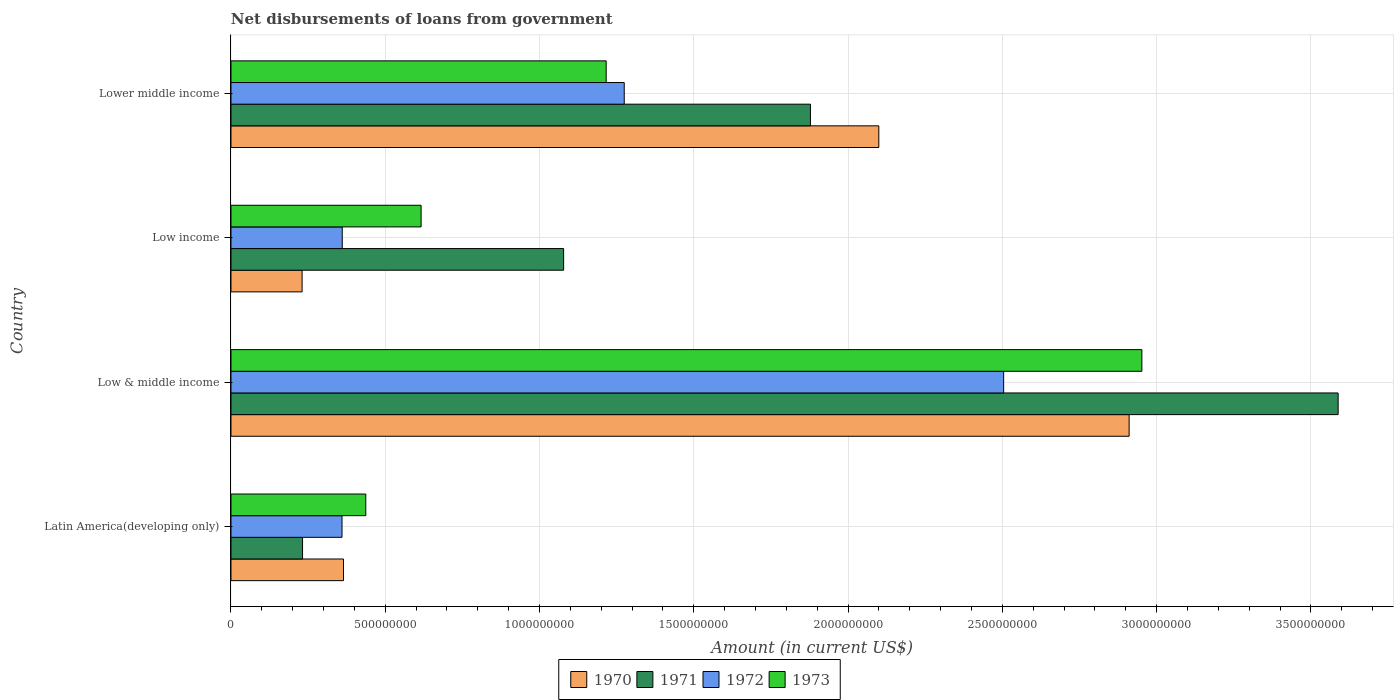How many groups of bars are there?
Your answer should be very brief. 4. How many bars are there on the 1st tick from the top?
Keep it short and to the point. 4. What is the label of the 2nd group of bars from the top?
Your answer should be compact. Low income. What is the amount of loan disbursed from government in 1971 in Low income?
Offer a terse response. 1.08e+09. Across all countries, what is the maximum amount of loan disbursed from government in 1973?
Your answer should be compact. 2.95e+09. Across all countries, what is the minimum amount of loan disbursed from government in 1971?
Offer a terse response. 2.32e+08. In which country was the amount of loan disbursed from government in 1971 maximum?
Offer a terse response. Low & middle income. In which country was the amount of loan disbursed from government in 1972 minimum?
Make the answer very short. Latin America(developing only). What is the total amount of loan disbursed from government in 1971 in the graph?
Provide a succinct answer. 6.78e+09. What is the difference between the amount of loan disbursed from government in 1971 in Latin America(developing only) and that in Lower middle income?
Your answer should be compact. -1.65e+09. What is the difference between the amount of loan disbursed from government in 1972 in Latin America(developing only) and the amount of loan disbursed from government in 1970 in Lower middle income?
Give a very brief answer. -1.74e+09. What is the average amount of loan disbursed from government in 1970 per country?
Your response must be concise. 1.40e+09. What is the difference between the amount of loan disbursed from government in 1971 and amount of loan disbursed from government in 1972 in Low income?
Provide a succinct answer. 7.17e+08. What is the ratio of the amount of loan disbursed from government in 1971 in Latin America(developing only) to that in Lower middle income?
Keep it short and to the point. 0.12. Is the amount of loan disbursed from government in 1971 in Low & middle income less than that in Lower middle income?
Ensure brevity in your answer.  No. Is the difference between the amount of loan disbursed from government in 1971 in Low income and Lower middle income greater than the difference between the amount of loan disbursed from government in 1972 in Low income and Lower middle income?
Provide a short and direct response. Yes. What is the difference between the highest and the second highest amount of loan disbursed from government in 1970?
Keep it short and to the point. 8.11e+08. What is the difference between the highest and the lowest amount of loan disbursed from government in 1972?
Give a very brief answer. 2.14e+09. In how many countries, is the amount of loan disbursed from government in 1972 greater than the average amount of loan disbursed from government in 1972 taken over all countries?
Provide a short and direct response. 2. Is it the case that in every country, the sum of the amount of loan disbursed from government in 1970 and amount of loan disbursed from government in 1971 is greater than the sum of amount of loan disbursed from government in 1973 and amount of loan disbursed from government in 1972?
Offer a terse response. No. What does the 4th bar from the bottom in Low income represents?
Keep it short and to the point. 1973. Is it the case that in every country, the sum of the amount of loan disbursed from government in 1971 and amount of loan disbursed from government in 1972 is greater than the amount of loan disbursed from government in 1970?
Offer a terse response. Yes. How many bars are there?
Your answer should be very brief. 16. How many countries are there in the graph?
Your response must be concise. 4. What is the difference between two consecutive major ticks on the X-axis?
Provide a succinct answer. 5.00e+08. Are the values on the major ticks of X-axis written in scientific E-notation?
Provide a succinct answer. No. Does the graph contain any zero values?
Keep it short and to the point. No. Does the graph contain grids?
Your response must be concise. Yes. How many legend labels are there?
Offer a terse response. 4. How are the legend labels stacked?
Provide a succinct answer. Horizontal. What is the title of the graph?
Provide a short and direct response. Net disbursements of loans from government. Does "1992" appear as one of the legend labels in the graph?
Keep it short and to the point. No. What is the label or title of the X-axis?
Keep it short and to the point. Amount (in current US$). What is the label or title of the Y-axis?
Your response must be concise. Country. What is the Amount (in current US$) in 1970 in Latin America(developing only)?
Provide a succinct answer. 3.65e+08. What is the Amount (in current US$) in 1971 in Latin America(developing only)?
Your response must be concise. 2.32e+08. What is the Amount (in current US$) in 1972 in Latin America(developing only)?
Offer a very short reply. 3.60e+08. What is the Amount (in current US$) of 1973 in Latin America(developing only)?
Your response must be concise. 4.37e+08. What is the Amount (in current US$) in 1970 in Low & middle income?
Ensure brevity in your answer.  2.91e+09. What is the Amount (in current US$) of 1971 in Low & middle income?
Your response must be concise. 3.59e+09. What is the Amount (in current US$) in 1972 in Low & middle income?
Your answer should be very brief. 2.50e+09. What is the Amount (in current US$) in 1973 in Low & middle income?
Keep it short and to the point. 2.95e+09. What is the Amount (in current US$) in 1970 in Low income?
Provide a short and direct response. 2.31e+08. What is the Amount (in current US$) of 1971 in Low income?
Offer a very short reply. 1.08e+09. What is the Amount (in current US$) in 1972 in Low income?
Provide a short and direct response. 3.61e+08. What is the Amount (in current US$) of 1973 in Low income?
Ensure brevity in your answer.  6.16e+08. What is the Amount (in current US$) in 1970 in Lower middle income?
Make the answer very short. 2.10e+09. What is the Amount (in current US$) in 1971 in Lower middle income?
Provide a short and direct response. 1.88e+09. What is the Amount (in current US$) in 1972 in Lower middle income?
Make the answer very short. 1.27e+09. What is the Amount (in current US$) of 1973 in Lower middle income?
Your answer should be very brief. 1.22e+09. Across all countries, what is the maximum Amount (in current US$) in 1970?
Offer a terse response. 2.91e+09. Across all countries, what is the maximum Amount (in current US$) in 1971?
Provide a succinct answer. 3.59e+09. Across all countries, what is the maximum Amount (in current US$) of 1972?
Your response must be concise. 2.50e+09. Across all countries, what is the maximum Amount (in current US$) of 1973?
Provide a succinct answer. 2.95e+09. Across all countries, what is the minimum Amount (in current US$) in 1970?
Offer a terse response. 2.31e+08. Across all countries, what is the minimum Amount (in current US$) of 1971?
Offer a very short reply. 2.32e+08. Across all countries, what is the minimum Amount (in current US$) of 1972?
Offer a terse response. 3.60e+08. Across all countries, what is the minimum Amount (in current US$) of 1973?
Your response must be concise. 4.37e+08. What is the total Amount (in current US$) of 1970 in the graph?
Offer a very short reply. 5.61e+09. What is the total Amount (in current US$) in 1971 in the graph?
Make the answer very short. 6.78e+09. What is the total Amount (in current US$) of 1972 in the graph?
Your response must be concise. 4.50e+09. What is the total Amount (in current US$) in 1973 in the graph?
Your answer should be compact. 5.22e+09. What is the difference between the Amount (in current US$) in 1970 in Latin America(developing only) and that in Low & middle income?
Your response must be concise. -2.55e+09. What is the difference between the Amount (in current US$) of 1971 in Latin America(developing only) and that in Low & middle income?
Offer a terse response. -3.36e+09. What is the difference between the Amount (in current US$) in 1972 in Latin America(developing only) and that in Low & middle income?
Offer a terse response. -2.14e+09. What is the difference between the Amount (in current US$) of 1973 in Latin America(developing only) and that in Low & middle income?
Give a very brief answer. -2.52e+09. What is the difference between the Amount (in current US$) in 1970 in Latin America(developing only) and that in Low income?
Offer a very short reply. 1.34e+08. What is the difference between the Amount (in current US$) in 1971 in Latin America(developing only) and that in Low income?
Offer a very short reply. -8.46e+08. What is the difference between the Amount (in current US$) of 1972 in Latin America(developing only) and that in Low income?
Offer a very short reply. -7.43e+05. What is the difference between the Amount (in current US$) of 1973 in Latin America(developing only) and that in Low income?
Your response must be concise. -1.79e+08. What is the difference between the Amount (in current US$) in 1970 in Latin America(developing only) and that in Lower middle income?
Ensure brevity in your answer.  -1.73e+09. What is the difference between the Amount (in current US$) in 1971 in Latin America(developing only) and that in Lower middle income?
Your answer should be compact. -1.65e+09. What is the difference between the Amount (in current US$) of 1972 in Latin America(developing only) and that in Lower middle income?
Offer a very short reply. -9.15e+08. What is the difference between the Amount (in current US$) of 1973 in Latin America(developing only) and that in Lower middle income?
Offer a very short reply. -7.79e+08. What is the difference between the Amount (in current US$) in 1970 in Low & middle income and that in Low income?
Keep it short and to the point. 2.68e+09. What is the difference between the Amount (in current US$) of 1971 in Low & middle income and that in Low income?
Provide a short and direct response. 2.51e+09. What is the difference between the Amount (in current US$) of 1972 in Low & middle income and that in Low income?
Provide a succinct answer. 2.14e+09. What is the difference between the Amount (in current US$) of 1973 in Low & middle income and that in Low income?
Offer a very short reply. 2.34e+09. What is the difference between the Amount (in current US$) in 1970 in Low & middle income and that in Lower middle income?
Give a very brief answer. 8.11e+08. What is the difference between the Amount (in current US$) in 1971 in Low & middle income and that in Lower middle income?
Offer a very short reply. 1.71e+09. What is the difference between the Amount (in current US$) in 1972 in Low & middle income and that in Lower middle income?
Provide a short and direct response. 1.23e+09. What is the difference between the Amount (in current US$) in 1973 in Low & middle income and that in Lower middle income?
Ensure brevity in your answer.  1.74e+09. What is the difference between the Amount (in current US$) in 1970 in Low income and that in Lower middle income?
Your response must be concise. -1.87e+09. What is the difference between the Amount (in current US$) of 1971 in Low income and that in Lower middle income?
Offer a very short reply. -8.00e+08. What is the difference between the Amount (in current US$) of 1972 in Low income and that in Lower middle income?
Provide a succinct answer. -9.14e+08. What is the difference between the Amount (in current US$) in 1973 in Low income and that in Lower middle income?
Provide a succinct answer. -6.00e+08. What is the difference between the Amount (in current US$) in 1970 in Latin America(developing only) and the Amount (in current US$) in 1971 in Low & middle income?
Your response must be concise. -3.22e+09. What is the difference between the Amount (in current US$) of 1970 in Latin America(developing only) and the Amount (in current US$) of 1972 in Low & middle income?
Your response must be concise. -2.14e+09. What is the difference between the Amount (in current US$) of 1970 in Latin America(developing only) and the Amount (in current US$) of 1973 in Low & middle income?
Your answer should be very brief. -2.59e+09. What is the difference between the Amount (in current US$) of 1971 in Latin America(developing only) and the Amount (in current US$) of 1972 in Low & middle income?
Your response must be concise. -2.27e+09. What is the difference between the Amount (in current US$) in 1971 in Latin America(developing only) and the Amount (in current US$) in 1973 in Low & middle income?
Your response must be concise. -2.72e+09. What is the difference between the Amount (in current US$) in 1972 in Latin America(developing only) and the Amount (in current US$) in 1973 in Low & middle income?
Keep it short and to the point. -2.59e+09. What is the difference between the Amount (in current US$) of 1970 in Latin America(developing only) and the Amount (in current US$) of 1971 in Low income?
Provide a short and direct response. -7.13e+08. What is the difference between the Amount (in current US$) of 1970 in Latin America(developing only) and the Amount (in current US$) of 1972 in Low income?
Your answer should be compact. 4.02e+06. What is the difference between the Amount (in current US$) in 1970 in Latin America(developing only) and the Amount (in current US$) in 1973 in Low income?
Your answer should be compact. -2.52e+08. What is the difference between the Amount (in current US$) of 1971 in Latin America(developing only) and the Amount (in current US$) of 1972 in Low income?
Keep it short and to the point. -1.29e+08. What is the difference between the Amount (in current US$) of 1971 in Latin America(developing only) and the Amount (in current US$) of 1973 in Low income?
Make the answer very short. -3.84e+08. What is the difference between the Amount (in current US$) in 1972 in Latin America(developing only) and the Amount (in current US$) in 1973 in Low income?
Keep it short and to the point. -2.56e+08. What is the difference between the Amount (in current US$) of 1970 in Latin America(developing only) and the Amount (in current US$) of 1971 in Lower middle income?
Provide a succinct answer. -1.51e+09. What is the difference between the Amount (in current US$) in 1970 in Latin America(developing only) and the Amount (in current US$) in 1972 in Lower middle income?
Keep it short and to the point. -9.10e+08. What is the difference between the Amount (in current US$) of 1970 in Latin America(developing only) and the Amount (in current US$) of 1973 in Lower middle income?
Provide a short and direct response. -8.51e+08. What is the difference between the Amount (in current US$) of 1971 in Latin America(developing only) and the Amount (in current US$) of 1972 in Lower middle income?
Provide a short and direct response. -1.04e+09. What is the difference between the Amount (in current US$) in 1971 in Latin America(developing only) and the Amount (in current US$) in 1973 in Lower middle income?
Ensure brevity in your answer.  -9.84e+08. What is the difference between the Amount (in current US$) in 1972 in Latin America(developing only) and the Amount (in current US$) in 1973 in Lower middle income?
Give a very brief answer. -8.56e+08. What is the difference between the Amount (in current US$) in 1970 in Low & middle income and the Amount (in current US$) in 1971 in Low income?
Your answer should be compact. 1.83e+09. What is the difference between the Amount (in current US$) of 1970 in Low & middle income and the Amount (in current US$) of 1972 in Low income?
Offer a terse response. 2.55e+09. What is the difference between the Amount (in current US$) of 1970 in Low & middle income and the Amount (in current US$) of 1973 in Low income?
Your answer should be very brief. 2.29e+09. What is the difference between the Amount (in current US$) in 1971 in Low & middle income and the Amount (in current US$) in 1972 in Low income?
Your response must be concise. 3.23e+09. What is the difference between the Amount (in current US$) in 1971 in Low & middle income and the Amount (in current US$) in 1973 in Low income?
Your answer should be compact. 2.97e+09. What is the difference between the Amount (in current US$) of 1972 in Low & middle income and the Amount (in current US$) of 1973 in Low income?
Provide a short and direct response. 1.89e+09. What is the difference between the Amount (in current US$) of 1970 in Low & middle income and the Amount (in current US$) of 1971 in Lower middle income?
Offer a terse response. 1.03e+09. What is the difference between the Amount (in current US$) in 1970 in Low & middle income and the Amount (in current US$) in 1972 in Lower middle income?
Keep it short and to the point. 1.64e+09. What is the difference between the Amount (in current US$) of 1970 in Low & middle income and the Amount (in current US$) of 1973 in Lower middle income?
Your answer should be compact. 1.69e+09. What is the difference between the Amount (in current US$) in 1971 in Low & middle income and the Amount (in current US$) in 1972 in Lower middle income?
Make the answer very short. 2.31e+09. What is the difference between the Amount (in current US$) of 1971 in Low & middle income and the Amount (in current US$) of 1973 in Lower middle income?
Your answer should be very brief. 2.37e+09. What is the difference between the Amount (in current US$) in 1972 in Low & middle income and the Amount (in current US$) in 1973 in Lower middle income?
Offer a very short reply. 1.29e+09. What is the difference between the Amount (in current US$) of 1970 in Low income and the Amount (in current US$) of 1971 in Lower middle income?
Your answer should be very brief. -1.65e+09. What is the difference between the Amount (in current US$) of 1970 in Low income and the Amount (in current US$) of 1972 in Lower middle income?
Give a very brief answer. -1.04e+09. What is the difference between the Amount (in current US$) of 1970 in Low income and the Amount (in current US$) of 1973 in Lower middle income?
Your response must be concise. -9.85e+08. What is the difference between the Amount (in current US$) in 1971 in Low income and the Amount (in current US$) in 1972 in Lower middle income?
Keep it short and to the point. -1.96e+08. What is the difference between the Amount (in current US$) of 1971 in Low income and the Amount (in current US$) of 1973 in Lower middle income?
Provide a short and direct response. -1.38e+08. What is the difference between the Amount (in current US$) of 1972 in Low income and the Amount (in current US$) of 1973 in Lower middle income?
Give a very brief answer. -8.55e+08. What is the average Amount (in current US$) of 1970 per country?
Your response must be concise. 1.40e+09. What is the average Amount (in current US$) of 1971 per country?
Make the answer very short. 1.69e+09. What is the average Amount (in current US$) of 1972 per country?
Give a very brief answer. 1.12e+09. What is the average Amount (in current US$) in 1973 per country?
Your response must be concise. 1.31e+09. What is the difference between the Amount (in current US$) in 1970 and Amount (in current US$) in 1971 in Latin America(developing only)?
Your response must be concise. 1.33e+08. What is the difference between the Amount (in current US$) in 1970 and Amount (in current US$) in 1972 in Latin America(developing only)?
Provide a short and direct response. 4.76e+06. What is the difference between the Amount (in current US$) in 1970 and Amount (in current US$) in 1973 in Latin America(developing only)?
Keep it short and to the point. -7.22e+07. What is the difference between the Amount (in current US$) in 1971 and Amount (in current US$) in 1972 in Latin America(developing only)?
Offer a terse response. -1.28e+08. What is the difference between the Amount (in current US$) in 1971 and Amount (in current US$) in 1973 in Latin America(developing only)?
Give a very brief answer. -2.05e+08. What is the difference between the Amount (in current US$) of 1972 and Amount (in current US$) of 1973 in Latin America(developing only)?
Provide a succinct answer. -7.70e+07. What is the difference between the Amount (in current US$) in 1970 and Amount (in current US$) in 1971 in Low & middle income?
Provide a short and direct response. -6.77e+08. What is the difference between the Amount (in current US$) of 1970 and Amount (in current US$) of 1972 in Low & middle income?
Provide a succinct answer. 4.07e+08. What is the difference between the Amount (in current US$) of 1970 and Amount (in current US$) of 1973 in Low & middle income?
Your answer should be very brief. -4.13e+07. What is the difference between the Amount (in current US$) in 1971 and Amount (in current US$) in 1972 in Low & middle income?
Your answer should be compact. 1.08e+09. What is the difference between the Amount (in current US$) in 1971 and Amount (in current US$) in 1973 in Low & middle income?
Your answer should be compact. 6.36e+08. What is the difference between the Amount (in current US$) of 1972 and Amount (in current US$) of 1973 in Low & middle income?
Ensure brevity in your answer.  -4.48e+08. What is the difference between the Amount (in current US$) in 1970 and Amount (in current US$) in 1971 in Low income?
Your response must be concise. -8.48e+08. What is the difference between the Amount (in current US$) of 1970 and Amount (in current US$) of 1972 in Low income?
Offer a very short reply. -1.30e+08. What is the difference between the Amount (in current US$) in 1970 and Amount (in current US$) in 1973 in Low income?
Provide a succinct answer. -3.86e+08. What is the difference between the Amount (in current US$) of 1971 and Amount (in current US$) of 1972 in Low income?
Your answer should be very brief. 7.17e+08. What is the difference between the Amount (in current US$) in 1971 and Amount (in current US$) in 1973 in Low income?
Your answer should be compact. 4.62e+08. What is the difference between the Amount (in current US$) of 1972 and Amount (in current US$) of 1973 in Low income?
Your response must be concise. -2.56e+08. What is the difference between the Amount (in current US$) of 1970 and Amount (in current US$) of 1971 in Lower middle income?
Make the answer very short. 2.22e+08. What is the difference between the Amount (in current US$) in 1970 and Amount (in current US$) in 1972 in Lower middle income?
Your answer should be very brief. 8.25e+08. What is the difference between the Amount (in current US$) of 1970 and Amount (in current US$) of 1973 in Lower middle income?
Ensure brevity in your answer.  8.84e+08. What is the difference between the Amount (in current US$) of 1971 and Amount (in current US$) of 1972 in Lower middle income?
Keep it short and to the point. 6.03e+08. What is the difference between the Amount (in current US$) in 1971 and Amount (in current US$) in 1973 in Lower middle income?
Your response must be concise. 6.62e+08. What is the difference between the Amount (in current US$) in 1972 and Amount (in current US$) in 1973 in Lower middle income?
Your answer should be very brief. 5.86e+07. What is the ratio of the Amount (in current US$) in 1970 in Latin America(developing only) to that in Low & middle income?
Keep it short and to the point. 0.13. What is the ratio of the Amount (in current US$) of 1971 in Latin America(developing only) to that in Low & middle income?
Offer a terse response. 0.06. What is the ratio of the Amount (in current US$) of 1972 in Latin America(developing only) to that in Low & middle income?
Make the answer very short. 0.14. What is the ratio of the Amount (in current US$) in 1973 in Latin America(developing only) to that in Low & middle income?
Ensure brevity in your answer.  0.15. What is the ratio of the Amount (in current US$) of 1970 in Latin America(developing only) to that in Low income?
Provide a succinct answer. 1.58. What is the ratio of the Amount (in current US$) of 1971 in Latin America(developing only) to that in Low income?
Provide a succinct answer. 0.22. What is the ratio of the Amount (in current US$) of 1973 in Latin America(developing only) to that in Low income?
Ensure brevity in your answer.  0.71. What is the ratio of the Amount (in current US$) in 1970 in Latin America(developing only) to that in Lower middle income?
Make the answer very short. 0.17. What is the ratio of the Amount (in current US$) of 1971 in Latin America(developing only) to that in Lower middle income?
Offer a terse response. 0.12. What is the ratio of the Amount (in current US$) of 1972 in Latin America(developing only) to that in Lower middle income?
Make the answer very short. 0.28. What is the ratio of the Amount (in current US$) in 1973 in Latin America(developing only) to that in Lower middle income?
Make the answer very short. 0.36. What is the ratio of the Amount (in current US$) of 1970 in Low & middle income to that in Low income?
Make the answer very short. 12.63. What is the ratio of the Amount (in current US$) in 1971 in Low & middle income to that in Low income?
Give a very brief answer. 3.33. What is the ratio of the Amount (in current US$) of 1972 in Low & middle income to that in Low income?
Your response must be concise. 6.94. What is the ratio of the Amount (in current US$) of 1973 in Low & middle income to that in Low income?
Offer a terse response. 4.79. What is the ratio of the Amount (in current US$) in 1970 in Low & middle income to that in Lower middle income?
Provide a short and direct response. 1.39. What is the ratio of the Amount (in current US$) of 1971 in Low & middle income to that in Lower middle income?
Offer a terse response. 1.91. What is the ratio of the Amount (in current US$) of 1972 in Low & middle income to that in Lower middle income?
Offer a very short reply. 1.96. What is the ratio of the Amount (in current US$) of 1973 in Low & middle income to that in Lower middle income?
Provide a succinct answer. 2.43. What is the ratio of the Amount (in current US$) of 1970 in Low income to that in Lower middle income?
Your response must be concise. 0.11. What is the ratio of the Amount (in current US$) of 1971 in Low income to that in Lower middle income?
Your response must be concise. 0.57. What is the ratio of the Amount (in current US$) in 1972 in Low income to that in Lower middle income?
Make the answer very short. 0.28. What is the ratio of the Amount (in current US$) in 1973 in Low income to that in Lower middle income?
Offer a terse response. 0.51. What is the difference between the highest and the second highest Amount (in current US$) of 1970?
Your response must be concise. 8.11e+08. What is the difference between the highest and the second highest Amount (in current US$) of 1971?
Provide a short and direct response. 1.71e+09. What is the difference between the highest and the second highest Amount (in current US$) in 1972?
Give a very brief answer. 1.23e+09. What is the difference between the highest and the second highest Amount (in current US$) in 1973?
Make the answer very short. 1.74e+09. What is the difference between the highest and the lowest Amount (in current US$) of 1970?
Offer a terse response. 2.68e+09. What is the difference between the highest and the lowest Amount (in current US$) of 1971?
Your response must be concise. 3.36e+09. What is the difference between the highest and the lowest Amount (in current US$) of 1972?
Keep it short and to the point. 2.14e+09. What is the difference between the highest and the lowest Amount (in current US$) in 1973?
Keep it short and to the point. 2.52e+09. 